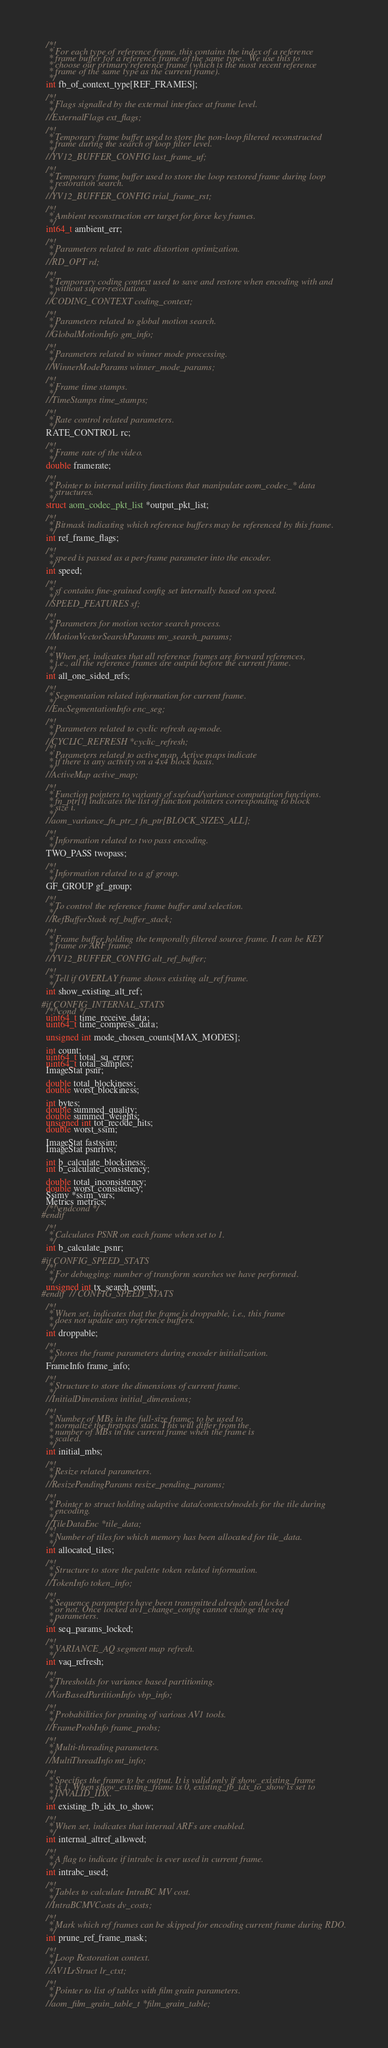Convert code to text. <code><loc_0><loc_0><loc_500><loc_500><_C_>  /*!
   * For each type of reference frame, this contains the index of a reference
   * frame buffer for a reference frame of the same type.  We use this to
   * choose our primary reference frame (which is the most recent reference
   * frame of the same type as the current frame).
   */
  int fb_of_context_type[REF_FRAMES];

  /*!
   * Flags signalled by the external interface at frame level.
   */
  //ExternalFlags ext_flags;

  /*!
   * Temporary frame buffer used to store the non-loop filtered reconstructed
   * frame during the search of loop filter level.
   */
  //YV12_BUFFER_CONFIG last_frame_uf;

  /*!
   * Temporary frame buffer used to store the loop restored frame during loop
   * restoration search.
   */
  //YV12_BUFFER_CONFIG trial_frame_rst;

  /*!
   * Ambient reconstruction err target for force key frames.
   */
  int64_t ambient_err;

  /*!
   * Parameters related to rate distortion optimization.
   */
  //RD_OPT rd;

  /*!
   * Temporary coding context used to save and restore when encoding with and
   * without super-resolution.
   */
  //CODING_CONTEXT coding_context;

  /*!
   * Parameters related to global motion search.
   */
  //GlobalMotionInfo gm_info;

  /*!
   * Parameters related to winner mode processing.
   */
  //WinnerModeParams winner_mode_params;

  /*!
   * Frame time stamps.
   */
  //TimeStamps time_stamps;

  /*!
   * Rate control related parameters.
   */
  RATE_CONTROL rc;

  /*!
   * Frame rate of the video.
   */
  double framerate;

  /*!
   * Pointer to internal utility functions that manipulate aom_codec_* data
   * structures.
   */
  struct aom_codec_pkt_list *output_pkt_list;

  /*!
   * Bitmask indicating which reference buffers may be referenced by this frame.
   */
  int ref_frame_flags;

  /*!
   * speed is passed as a per-frame parameter into the encoder.
   */
  int speed;

  /*!
   * sf contains fine-grained config set internally based on speed.
   */
  //SPEED_FEATURES sf;

  /*!
   * Parameters for motion vector search process.
   */
  //MotionVectorSearchParams mv_search_params;

  /*!
   * When set, indicates that all reference frames are forward references,
   * i.e., all the reference frames are output before the current frame.
   */
  int all_one_sided_refs;

  /*!
   * Segmentation related information for current frame.
   */
  //EncSegmentationInfo enc_seg;

  /*!
   * Parameters related to cyclic refresh aq-mode.
   */
  //CYCLIC_REFRESH *cyclic_refresh;
  /*!
   * Parameters related to active map. Active maps indicate
   * if there is any activity on a 4x4 block basis.
   */
  //ActiveMap active_map;

  /*!
   * Function pointers to variants of sse/sad/variance computation functions.
   * fn_ptr[i] indicates the list of function pointers corresponding to block
   * size i.
   */
  //aom_variance_fn_ptr_t fn_ptr[BLOCK_SIZES_ALL];

  /*!
   * Information related to two pass encoding.
   */
  TWO_PASS twopass;

  /*!
   * Information related to a gf group.
   */
  GF_GROUP gf_group;

  /*!
   * To control the reference frame buffer and selection.
   */
  //RefBufferStack ref_buffer_stack;

  /*!
   * Frame buffer holding the temporally filtered source frame. It can be KEY
   * frame or ARF frame.
   */
  //YV12_BUFFER_CONFIG alt_ref_buffer;

  /*!
   * Tell if OVERLAY frame shows existing alt_ref frame.
   */
  int show_existing_alt_ref;

#if CONFIG_INTERNAL_STATS
  /*!\cond */
  uint64_t time_receive_data;
  uint64_t time_compress_data;

  unsigned int mode_chosen_counts[MAX_MODES];

  int count;
  uint64_t total_sq_error;
  uint64_t total_samples;
  ImageStat psnr;

  double total_blockiness;
  double worst_blockiness;

  int bytes;
  double summed_quality;
  double summed_weights;
  unsigned int tot_recode_hits;
  double worst_ssim;

  ImageStat fastssim;
  ImageStat psnrhvs;

  int b_calculate_blockiness;
  int b_calculate_consistency;

  double total_inconsistency;
  double worst_consistency;
  Ssimv *ssim_vars;
  Metrics metrics;
  /*!\endcond */
#endif

  /*!
   * Calculates PSNR on each frame when set to 1.
   */
  int b_calculate_psnr;

#if CONFIG_SPEED_STATS
  /*!
   * For debugging: number of transform searches we have performed.
   */
  unsigned int tx_search_count;
#endif  // CONFIG_SPEED_STATS

  /*!
   * When set, indicates that the frame is droppable, i.e., this frame
   * does not update any reference buffers.
   */
  int droppable;

  /*!
   * Stores the frame parameters during encoder initialization.
   */
  FrameInfo frame_info;

  /*!
   * Structure to store the dimensions of current frame.
   */
  //InitialDimensions initial_dimensions;

  /*!
   * Number of MBs in the full-size frame; to be used to
   * normalize the firstpass stats. This will differ from the
   * number of MBs in the current frame when the frame is
   * scaled.
   */
  int initial_mbs;

  /*!
   * Resize related parameters.
   */
  //ResizePendingParams resize_pending_params;

  /*!
   * Pointer to struct holding adaptive data/contexts/models for the tile during
   * encoding.
   */
  //TileDataEnc *tile_data;
  /*!
   * Number of tiles for which memory has been allocated for tile_data.
   */
  int allocated_tiles;

  /*!
   * Structure to store the palette token related information.
   */
  //TokenInfo token_info;

  /*!
   * Sequence parameters have been transmitted already and locked
   * or not. Once locked av1_change_config cannot change the seq
   * parameters.
   */
  int seq_params_locked;

  /*!
   * VARIANCE_AQ segment map refresh.
   */
  int vaq_refresh;

  /*!
   * Thresholds for variance based partitioning.
   */
  //VarBasedPartitionInfo vbp_info;

  /*!
   * Probabilities for pruning of various AV1 tools.
   */
  //FrameProbInfo frame_probs;

  /*!
   * Multi-threading parameters.
   */
  //MultiThreadInfo mt_info;

  /*!
   * Specifies the frame to be output. It is valid only if show_existing_frame
   * is 1. When show_existing_frame is 0, existing_fb_idx_to_show is set to
   * INVALID_IDX.
   */
  int existing_fb_idx_to_show;

  /*!
   * When set, indicates that internal ARFs are enabled.
   */
  int internal_altref_allowed;

  /*!
   * A flag to indicate if intrabc is ever used in current frame.
   */
  int intrabc_used;

  /*!
   * Tables to calculate IntraBC MV cost.
   */
  //IntraBCMVCosts dv_costs;

  /*!
   * Mark which ref frames can be skipped for encoding current frame during RDO.
   */
  int prune_ref_frame_mask;

  /*!
   * Loop Restoration context.
   */
  //AV1LrStruct lr_ctxt;

  /*!
   * Pointer to list of tables with film grain parameters.
   */
  //aom_film_grain_table_t *film_grain_table;
</code> 